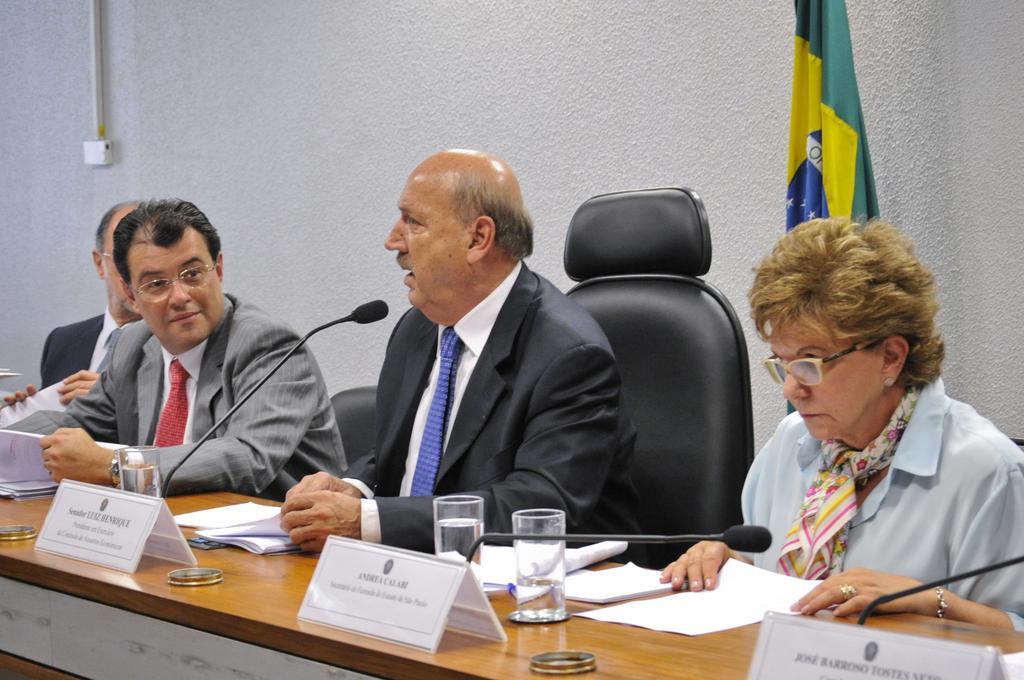Could you give a brief overview of what you see in this image? In this image I can see few persons are sitting on chairs which are black in color in front of the brown colored desk. On the desk I can see few glasses, few papers, few microphones and few white colored boards. In the background I can see the white colored wall and the flag. 